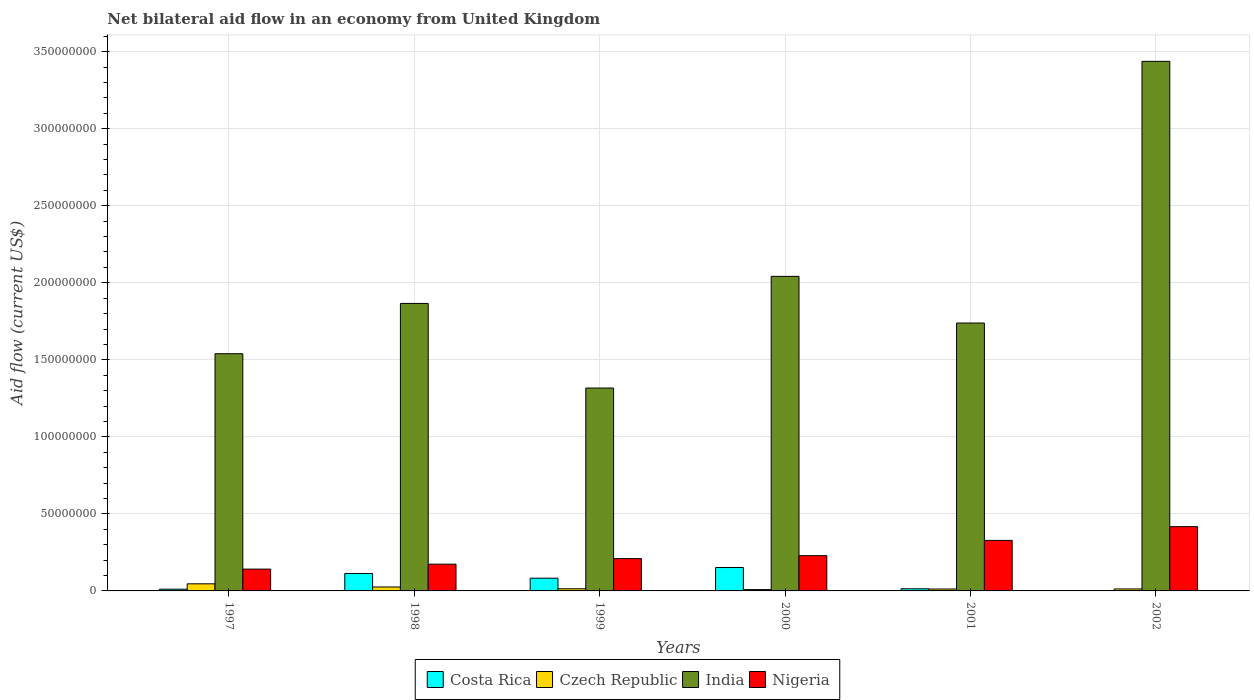How many groups of bars are there?
Provide a short and direct response. 6. Are the number of bars per tick equal to the number of legend labels?
Your answer should be compact. No. Are the number of bars on each tick of the X-axis equal?
Provide a short and direct response. No. How many bars are there on the 4th tick from the right?
Give a very brief answer. 4. What is the label of the 3rd group of bars from the left?
Offer a terse response. 1999. In how many cases, is the number of bars for a given year not equal to the number of legend labels?
Your answer should be compact. 1. What is the net bilateral aid flow in Nigeria in 1999?
Give a very brief answer. 2.10e+07. Across all years, what is the maximum net bilateral aid flow in Nigeria?
Keep it short and to the point. 4.17e+07. Across all years, what is the minimum net bilateral aid flow in Nigeria?
Provide a short and direct response. 1.42e+07. In which year was the net bilateral aid flow in Czech Republic maximum?
Offer a very short reply. 1997. What is the total net bilateral aid flow in India in the graph?
Offer a terse response. 1.19e+09. What is the difference between the net bilateral aid flow in Czech Republic in 1999 and that in 2002?
Provide a succinct answer. 1.10e+05. What is the average net bilateral aid flow in Czech Republic per year?
Provide a short and direct response. 1.99e+06. In the year 1997, what is the difference between the net bilateral aid flow in Costa Rica and net bilateral aid flow in Nigeria?
Offer a very short reply. -1.30e+07. In how many years, is the net bilateral aid flow in Costa Rica greater than 240000000 US$?
Make the answer very short. 0. What is the ratio of the net bilateral aid flow in Nigeria in 1997 to that in 1998?
Your answer should be very brief. 0.82. Is the net bilateral aid flow in Nigeria in 1998 less than that in 1999?
Ensure brevity in your answer.  Yes. What is the difference between the highest and the second highest net bilateral aid flow in Nigeria?
Keep it short and to the point. 8.92e+06. What is the difference between the highest and the lowest net bilateral aid flow in India?
Your response must be concise. 2.12e+08. In how many years, is the net bilateral aid flow in Czech Republic greater than the average net bilateral aid flow in Czech Republic taken over all years?
Offer a very short reply. 2. Is the sum of the net bilateral aid flow in Czech Republic in 1997 and 1998 greater than the maximum net bilateral aid flow in India across all years?
Offer a terse response. No. Is it the case that in every year, the sum of the net bilateral aid flow in India and net bilateral aid flow in Czech Republic is greater than the sum of net bilateral aid flow in Nigeria and net bilateral aid flow in Costa Rica?
Provide a succinct answer. Yes. How many bars are there?
Your response must be concise. 23. How many years are there in the graph?
Provide a succinct answer. 6. What is the difference between two consecutive major ticks on the Y-axis?
Provide a succinct answer. 5.00e+07. Are the values on the major ticks of Y-axis written in scientific E-notation?
Offer a very short reply. No. Does the graph contain any zero values?
Your answer should be very brief. Yes. Where does the legend appear in the graph?
Provide a short and direct response. Bottom center. What is the title of the graph?
Provide a succinct answer. Net bilateral aid flow in an economy from United Kingdom. Does "St. Kitts and Nevis" appear as one of the legend labels in the graph?
Your answer should be very brief. No. What is the Aid flow (current US$) in Costa Rica in 1997?
Provide a succinct answer. 1.12e+06. What is the Aid flow (current US$) in Czech Republic in 1997?
Your answer should be compact. 4.61e+06. What is the Aid flow (current US$) in India in 1997?
Your response must be concise. 1.54e+08. What is the Aid flow (current US$) in Nigeria in 1997?
Your answer should be compact. 1.42e+07. What is the Aid flow (current US$) in Costa Rica in 1998?
Your response must be concise. 1.13e+07. What is the Aid flow (current US$) in Czech Republic in 1998?
Your answer should be very brief. 2.56e+06. What is the Aid flow (current US$) in India in 1998?
Offer a terse response. 1.87e+08. What is the Aid flow (current US$) of Nigeria in 1998?
Your response must be concise. 1.74e+07. What is the Aid flow (current US$) of Costa Rica in 1999?
Make the answer very short. 8.27e+06. What is the Aid flow (current US$) in Czech Republic in 1999?
Keep it short and to the point. 1.39e+06. What is the Aid flow (current US$) in India in 1999?
Your response must be concise. 1.32e+08. What is the Aid flow (current US$) of Nigeria in 1999?
Offer a terse response. 2.10e+07. What is the Aid flow (current US$) in Costa Rica in 2000?
Offer a very short reply. 1.52e+07. What is the Aid flow (current US$) of Czech Republic in 2000?
Offer a very short reply. 8.70e+05. What is the Aid flow (current US$) in India in 2000?
Provide a short and direct response. 2.04e+08. What is the Aid flow (current US$) of Nigeria in 2000?
Keep it short and to the point. 2.29e+07. What is the Aid flow (current US$) in Costa Rica in 2001?
Your response must be concise. 1.39e+06. What is the Aid flow (current US$) in Czech Republic in 2001?
Your answer should be compact. 1.24e+06. What is the Aid flow (current US$) in India in 2001?
Ensure brevity in your answer.  1.74e+08. What is the Aid flow (current US$) in Nigeria in 2001?
Keep it short and to the point. 3.28e+07. What is the Aid flow (current US$) of Costa Rica in 2002?
Your response must be concise. 0. What is the Aid flow (current US$) in Czech Republic in 2002?
Provide a succinct answer. 1.28e+06. What is the Aid flow (current US$) of India in 2002?
Give a very brief answer. 3.44e+08. What is the Aid flow (current US$) in Nigeria in 2002?
Give a very brief answer. 4.17e+07. Across all years, what is the maximum Aid flow (current US$) of Costa Rica?
Offer a very short reply. 1.52e+07. Across all years, what is the maximum Aid flow (current US$) in Czech Republic?
Provide a succinct answer. 4.61e+06. Across all years, what is the maximum Aid flow (current US$) of India?
Keep it short and to the point. 3.44e+08. Across all years, what is the maximum Aid flow (current US$) in Nigeria?
Make the answer very short. 4.17e+07. Across all years, what is the minimum Aid flow (current US$) of Costa Rica?
Offer a terse response. 0. Across all years, what is the minimum Aid flow (current US$) of Czech Republic?
Ensure brevity in your answer.  8.70e+05. Across all years, what is the minimum Aid flow (current US$) of India?
Your response must be concise. 1.32e+08. Across all years, what is the minimum Aid flow (current US$) of Nigeria?
Offer a very short reply. 1.42e+07. What is the total Aid flow (current US$) in Costa Rica in the graph?
Your answer should be very brief. 3.73e+07. What is the total Aid flow (current US$) of Czech Republic in the graph?
Ensure brevity in your answer.  1.20e+07. What is the total Aid flow (current US$) in India in the graph?
Your response must be concise. 1.19e+09. What is the total Aid flow (current US$) in Nigeria in the graph?
Keep it short and to the point. 1.50e+08. What is the difference between the Aid flow (current US$) of Costa Rica in 1997 and that in 1998?
Your answer should be compact. -1.02e+07. What is the difference between the Aid flow (current US$) in Czech Republic in 1997 and that in 1998?
Your answer should be very brief. 2.05e+06. What is the difference between the Aid flow (current US$) in India in 1997 and that in 1998?
Your answer should be compact. -3.26e+07. What is the difference between the Aid flow (current US$) in Nigeria in 1997 and that in 1998?
Your response must be concise. -3.21e+06. What is the difference between the Aid flow (current US$) in Costa Rica in 1997 and that in 1999?
Make the answer very short. -7.15e+06. What is the difference between the Aid flow (current US$) of Czech Republic in 1997 and that in 1999?
Ensure brevity in your answer.  3.22e+06. What is the difference between the Aid flow (current US$) in India in 1997 and that in 1999?
Provide a short and direct response. 2.23e+07. What is the difference between the Aid flow (current US$) in Nigeria in 1997 and that in 1999?
Make the answer very short. -6.83e+06. What is the difference between the Aid flow (current US$) in Costa Rica in 1997 and that in 2000?
Offer a terse response. -1.41e+07. What is the difference between the Aid flow (current US$) in Czech Republic in 1997 and that in 2000?
Provide a succinct answer. 3.74e+06. What is the difference between the Aid flow (current US$) in India in 1997 and that in 2000?
Keep it short and to the point. -5.02e+07. What is the difference between the Aid flow (current US$) in Nigeria in 1997 and that in 2000?
Provide a short and direct response. -8.74e+06. What is the difference between the Aid flow (current US$) of Costa Rica in 1997 and that in 2001?
Ensure brevity in your answer.  -2.70e+05. What is the difference between the Aid flow (current US$) of Czech Republic in 1997 and that in 2001?
Offer a very short reply. 3.37e+06. What is the difference between the Aid flow (current US$) in India in 1997 and that in 2001?
Offer a very short reply. -1.99e+07. What is the difference between the Aid flow (current US$) in Nigeria in 1997 and that in 2001?
Your answer should be compact. -1.86e+07. What is the difference between the Aid flow (current US$) of Czech Republic in 1997 and that in 2002?
Give a very brief answer. 3.33e+06. What is the difference between the Aid flow (current US$) in India in 1997 and that in 2002?
Provide a succinct answer. -1.90e+08. What is the difference between the Aid flow (current US$) of Nigeria in 1997 and that in 2002?
Your response must be concise. -2.76e+07. What is the difference between the Aid flow (current US$) of Costa Rica in 1998 and that in 1999?
Offer a very short reply. 3.06e+06. What is the difference between the Aid flow (current US$) in Czech Republic in 1998 and that in 1999?
Offer a terse response. 1.17e+06. What is the difference between the Aid flow (current US$) in India in 1998 and that in 1999?
Provide a succinct answer. 5.49e+07. What is the difference between the Aid flow (current US$) of Nigeria in 1998 and that in 1999?
Your answer should be very brief. -3.62e+06. What is the difference between the Aid flow (current US$) of Costa Rica in 1998 and that in 2000?
Ensure brevity in your answer.  -3.86e+06. What is the difference between the Aid flow (current US$) of Czech Republic in 1998 and that in 2000?
Your response must be concise. 1.69e+06. What is the difference between the Aid flow (current US$) of India in 1998 and that in 2000?
Offer a very short reply. -1.76e+07. What is the difference between the Aid flow (current US$) in Nigeria in 1998 and that in 2000?
Provide a succinct answer. -5.53e+06. What is the difference between the Aid flow (current US$) in Costa Rica in 1998 and that in 2001?
Ensure brevity in your answer.  9.94e+06. What is the difference between the Aid flow (current US$) of Czech Republic in 1998 and that in 2001?
Provide a short and direct response. 1.32e+06. What is the difference between the Aid flow (current US$) of India in 1998 and that in 2001?
Your response must be concise. 1.27e+07. What is the difference between the Aid flow (current US$) in Nigeria in 1998 and that in 2001?
Make the answer very short. -1.54e+07. What is the difference between the Aid flow (current US$) in Czech Republic in 1998 and that in 2002?
Give a very brief answer. 1.28e+06. What is the difference between the Aid flow (current US$) of India in 1998 and that in 2002?
Give a very brief answer. -1.57e+08. What is the difference between the Aid flow (current US$) in Nigeria in 1998 and that in 2002?
Give a very brief answer. -2.44e+07. What is the difference between the Aid flow (current US$) of Costa Rica in 1999 and that in 2000?
Ensure brevity in your answer.  -6.92e+06. What is the difference between the Aid flow (current US$) in Czech Republic in 1999 and that in 2000?
Offer a terse response. 5.20e+05. What is the difference between the Aid flow (current US$) in India in 1999 and that in 2000?
Provide a succinct answer. -7.25e+07. What is the difference between the Aid flow (current US$) of Nigeria in 1999 and that in 2000?
Your answer should be compact. -1.91e+06. What is the difference between the Aid flow (current US$) in Costa Rica in 1999 and that in 2001?
Provide a short and direct response. 6.88e+06. What is the difference between the Aid flow (current US$) of Czech Republic in 1999 and that in 2001?
Your response must be concise. 1.50e+05. What is the difference between the Aid flow (current US$) in India in 1999 and that in 2001?
Give a very brief answer. -4.22e+07. What is the difference between the Aid flow (current US$) of Nigeria in 1999 and that in 2001?
Ensure brevity in your answer.  -1.18e+07. What is the difference between the Aid flow (current US$) in India in 1999 and that in 2002?
Provide a short and direct response. -2.12e+08. What is the difference between the Aid flow (current US$) in Nigeria in 1999 and that in 2002?
Offer a terse response. -2.07e+07. What is the difference between the Aid flow (current US$) of Costa Rica in 2000 and that in 2001?
Provide a short and direct response. 1.38e+07. What is the difference between the Aid flow (current US$) in Czech Republic in 2000 and that in 2001?
Offer a very short reply. -3.70e+05. What is the difference between the Aid flow (current US$) of India in 2000 and that in 2001?
Your response must be concise. 3.03e+07. What is the difference between the Aid flow (current US$) of Nigeria in 2000 and that in 2001?
Your answer should be very brief. -9.90e+06. What is the difference between the Aid flow (current US$) in Czech Republic in 2000 and that in 2002?
Offer a terse response. -4.10e+05. What is the difference between the Aid flow (current US$) in India in 2000 and that in 2002?
Your response must be concise. -1.40e+08. What is the difference between the Aid flow (current US$) in Nigeria in 2000 and that in 2002?
Give a very brief answer. -1.88e+07. What is the difference between the Aid flow (current US$) in Czech Republic in 2001 and that in 2002?
Give a very brief answer. -4.00e+04. What is the difference between the Aid flow (current US$) in India in 2001 and that in 2002?
Keep it short and to the point. -1.70e+08. What is the difference between the Aid flow (current US$) of Nigeria in 2001 and that in 2002?
Your response must be concise. -8.92e+06. What is the difference between the Aid flow (current US$) of Costa Rica in 1997 and the Aid flow (current US$) of Czech Republic in 1998?
Your answer should be compact. -1.44e+06. What is the difference between the Aid flow (current US$) of Costa Rica in 1997 and the Aid flow (current US$) of India in 1998?
Your answer should be very brief. -1.85e+08. What is the difference between the Aid flow (current US$) in Costa Rica in 1997 and the Aid flow (current US$) in Nigeria in 1998?
Your answer should be compact. -1.62e+07. What is the difference between the Aid flow (current US$) in Czech Republic in 1997 and the Aid flow (current US$) in India in 1998?
Offer a terse response. -1.82e+08. What is the difference between the Aid flow (current US$) of Czech Republic in 1997 and the Aid flow (current US$) of Nigeria in 1998?
Provide a short and direct response. -1.28e+07. What is the difference between the Aid flow (current US$) of India in 1997 and the Aid flow (current US$) of Nigeria in 1998?
Make the answer very short. 1.37e+08. What is the difference between the Aid flow (current US$) of Costa Rica in 1997 and the Aid flow (current US$) of Czech Republic in 1999?
Ensure brevity in your answer.  -2.70e+05. What is the difference between the Aid flow (current US$) of Costa Rica in 1997 and the Aid flow (current US$) of India in 1999?
Give a very brief answer. -1.31e+08. What is the difference between the Aid flow (current US$) of Costa Rica in 1997 and the Aid flow (current US$) of Nigeria in 1999?
Your answer should be very brief. -1.99e+07. What is the difference between the Aid flow (current US$) in Czech Republic in 1997 and the Aid flow (current US$) in India in 1999?
Provide a short and direct response. -1.27e+08. What is the difference between the Aid flow (current US$) in Czech Republic in 1997 and the Aid flow (current US$) in Nigeria in 1999?
Your answer should be very brief. -1.64e+07. What is the difference between the Aid flow (current US$) of India in 1997 and the Aid flow (current US$) of Nigeria in 1999?
Offer a terse response. 1.33e+08. What is the difference between the Aid flow (current US$) in Costa Rica in 1997 and the Aid flow (current US$) in India in 2000?
Make the answer very short. -2.03e+08. What is the difference between the Aid flow (current US$) in Costa Rica in 1997 and the Aid flow (current US$) in Nigeria in 2000?
Your answer should be very brief. -2.18e+07. What is the difference between the Aid flow (current US$) in Czech Republic in 1997 and the Aid flow (current US$) in India in 2000?
Make the answer very short. -2.00e+08. What is the difference between the Aid flow (current US$) of Czech Republic in 1997 and the Aid flow (current US$) of Nigeria in 2000?
Give a very brief answer. -1.83e+07. What is the difference between the Aid flow (current US$) in India in 1997 and the Aid flow (current US$) in Nigeria in 2000?
Provide a short and direct response. 1.31e+08. What is the difference between the Aid flow (current US$) in Costa Rica in 1997 and the Aid flow (current US$) in India in 2001?
Offer a terse response. -1.73e+08. What is the difference between the Aid flow (current US$) in Costa Rica in 1997 and the Aid flow (current US$) in Nigeria in 2001?
Give a very brief answer. -3.17e+07. What is the difference between the Aid flow (current US$) of Czech Republic in 1997 and the Aid flow (current US$) of India in 2001?
Give a very brief answer. -1.69e+08. What is the difference between the Aid flow (current US$) in Czech Republic in 1997 and the Aid flow (current US$) in Nigeria in 2001?
Ensure brevity in your answer.  -2.82e+07. What is the difference between the Aid flow (current US$) in India in 1997 and the Aid flow (current US$) in Nigeria in 2001?
Make the answer very short. 1.21e+08. What is the difference between the Aid flow (current US$) of Costa Rica in 1997 and the Aid flow (current US$) of India in 2002?
Provide a short and direct response. -3.43e+08. What is the difference between the Aid flow (current US$) of Costa Rica in 1997 and the Aid flow (current US$) of Nigeria in 2002?
Make the answer very short. -4.06e+07. What is the difference between the Aid flow (current US$) of Czech Republic in 1997 and the Aid flow (current US$) of India in 2002?
Your response must be concise. -3.39e+08. What is the difference between the Aid flow (current US$) of Czech Republic in 1997 and the Aid flow (current US$) of Nigeria in 2002?
Your answer should be very brief. -3.71e+07. What is the difference between the Aid flow (current US$) of India in 1997 and the Aid flow (current US$) of Nigeria in 2002?
Your response must be concise. 1.12e+08. What is the difference between the Aid flow (current US$) in Costa Rica in 1998 and the Aid flow (current US$) in Czech Republic in 1999?
Provide a succinct answer. 9.94e+06. What is the difference between the Aid flow (current US$) in Costa Rica in 1998 and the Aid flow (current US$) in India in 1999?
Provide a succinct answer. -1.20e+08. What is the difference between the Aid flow (current US$) of Costa Rica in 1998 and the Aid flow (current US$) of Nigeria in 1999?
Make the answer very short. -9.65e+06. What is the difference between the Aid flow (current US$) in Czech Republic in 1998 and the Aid flow (current US$) in India in 1999?
Give a very brief answer. -1.29e+08. What is the difference between the Aid flow (current US$) in Czech Republic in 1998 and the Aid flow (current US$) in Nigeria in 1999?
Your answer should be compact. -1.84e+07. What is the difference between the Aid flow (current US$) in India in 1998 and the Aid flow (current US$) in Nigeria in 1999?
Offer a very short reply. 1.66e+08. What is the difference between the Aid flow (current US$) in Costa Rica in 1998 and the Aid flow (current US$) in Czech Republic in 2000?
Offer a very short reply. 1.05e+07. What is the difference between the Aid flow (current US$) in Costa Rica in 1998 and the Aid flow (current US$) in India in 2000?
Give a very brief answer. -1.93e+08. What is the difference between the Aid flow (current US$) in Costa Rica in 1998 and the Aid flow (current US$) in Nigeria in 2000?
Offer a terse response. -1.16e+07. What is the difference between the Aid flow (current US$) of Czech Republic in 1998 and the Aid flow (current US$) of India in 2000?
Give a very brief answer. -2.02e+08. What is the difference between the Aid flow (current US$) of Czech Republic in 1998 and the Aid flow (current US$) of Nigeria in 2000?
Offer a very short reply. -2.03e+07. What is the difference between the Aid flow (current US$) in India in 1998 and the Aid flow (current US$) in Nigeria in 2000?
Your answer should be compact. 1.64e+08. What is the difference between the Aid flow (current US$) in Costa Rica in 1998 and the Aid flow (current US$) in Czech Republic in 2001?
Provide a succinct answer. 1.01e+07. What is the difference between the Aid flow (current US$) of Costa Rica in 1998 and the Aid flow (current US$) of India in 2001?
Offer a terse response. -1.63e+08. What is the difference between the Aid flow (current US$) in Costa Rica in 1998 and the Aid flow (current US$) in Nigeria in 2001?
Make the answer very short. -2.15e+07. What is the difference between the Aid flow (current US$) of Czech Republic in 1998 and the Aid flow (current US$) of India in 2001?
Your response must be concise. -1.71e+08. What is the difference between the Aid flow (current US$) of Czech Republic in 1998 and the Aid flow (current US$) of Nigeria in 2001?
Offer a very short reply. -3.02e+07. What is the difference between the Aid flow (current US$) in India in 1998 and the Aid flow (current US$) in Nigeria in 2001?
Make the answer very short. 1.54e+08. What is the difference between the Aid flow (current US$) of Costa Rica in 1998 and the Aid flow (current US$) of Czech Republic in 2002?
Provide a short and direct response. 1.00e+07. What is the difference between the Aid flow (current US$) in Costa Rica in 1998 and the Aid flow (current US$) in India in 2002?
Your answer should be very brief. -3.32e+08. What is the difference between the Aid flow (current US$) in Costa Rica in 1998 and the Aid flow (current US$) in Nigeria in 2002?
Your answer should be compact. -3.04e+07. What is the difference between the Aid flow (current US$) of Czech Republic in 1998 and the Aid flow (current US$) of India in 2002?
Offer a terse response. -3.41e+08. What is the difference between the Aid flow (current US$) in Czech Republic in 1998 and the Aid flow (current US$) in Nigeria in 2002?
Your response must be concise. -3.92e+07. What is the difference between the Aid flow (current US$) of India in 1998 and the Aid flow (current US$) of Nigeria in 2002?
Your response must be concise. 1.45e+08. What is the difference between the Aid flow (current US$) of Costa Rica in 1999 and the Aid flow (current US$) of Czech Republic in 2000?
Offer a very short reply. 7.40e+06. What is the difference between the Aid flow (current US$) in Costa Rica in 1999 and the Aid flow (current US$) in India in 2000?
Your response must be concise. -1.96e+08. What is the difference between the Aid flow (current US$) of Costa Rica in 1999 and the Aid flow (current US$) of Nigeria in 2000?
Give a very brief answer. -1.46e+07. What is the difference between the Aid flow (current US$) in Czech Republic in 1999 and the Aid flow (current US$) in India in 2000?
Offer a terse response. -2.03e+08. What is the difference between the Aid flow (current US$) of Czech Republic in 1999 and the Aid flow (current US$) of Nigeria in 2000?
Make the answer very short. -2.15e+07. What is the difference between the Aid flow (current US$) in India in 1999 and the Aid flow (current US$) in Nigeria in 2000?
Offer a terse response. 1.09e+08. What is the difference between the Aid flow (current US$) in Costa Rica in 1999 and the Aid flow (current US$) in Czech Republic in 2001?
Provide a succinct answer. 7.03e+06. What is the difference between the Aid flow (current US$) in Costa Rica in 1999 and the Aid flow (current US$) in India in 2001?
Give a very brief answer. -1.66e+08. What is the difference between the Aid flow (current US$) of Costa Rica in 1999 and the Aid flow (current US$) of Nigeria in 2001?
Provide a short and direct response. -2.45e+07. What is the difference between the Aid flow (current US$) of Czech Republic in 1999 and the Aid flow (current US$) of India in 2001?
Give a very brief answer. -1.72e+08. What is the difference between the Aid flow (current US$) of Czech Republic in 1999 and the Aid flow (current US$) of Nigeria in 2001?
Offer a terse response. -3.14e+07. What is the difference between the Aid flow (current US$) of India in 1999 and the Aid flow (current US$) of Nigeria in 2001?
Your answer should be compact. 9.89e+07. What is the difference between the Aid flow (current US$) of Costa Rica in 1999 and the Aid flow (current US$) of Czech Republic in 2002?
Provide a succinct answer. 6.99e+06. What is the difference between the Aid flow (current US$) of Costa Rica in 1999 and the Aid flow (current US$) of India in 2002?
Your response must be concise. -3.35e+08. What is the difference between the Aid flow (current US$) in Costa Rica in 1999 and the Aid flow (current US$) in Nigeria in 2002?
Ensure brevity in your answer.  -3.34e+07. What is the difference between the Aid flow (current US$) of Czech Republic in 1999 and the Aid flow (current US$) of India in 2002?
Your response must be concise. -3.42e+08. What is the difference between the Aid flow (current US$) in Czech Republic in 1999 and the Aid flow (current US$) in Nigeria in 2002?
Ensure brevity in your answer.  -4.03e+07. What is the difference between the Aid flow (current US$) of India in 1999 and the Aid flow (current US$) of Nigeria in 2002?
Provide a succinct answer. 9.00e+07. What is the difference between the Aid flow (current US$) of Costa Rica in 2000 and the Aid flow (current US$) of Czech Republic in 2001?
Give a very brief answer. 1.40e+07. What is the difference between the Aid flow (current US$) of Costa Rica in 2000 and the Aid flow (current US$) of India in 2001?
Offer a terse response. -1.59e+08. What is the difference between the Aid flow (current US$) in Costa Rica in 2000 and the Aid flow (current US$) in Nigeria in 2001?
Make the answer very short. -1.76e+07. What is the difference between the Aid flow (current US$) of Czech Republic in 2000 and the Aid flow (current US$) of India in 2001?
Provide a short and direct response. -1.73e+08. What is the difference between the Aid flow (current US$) in Czech Republic in 2000 and the Aid flow (current US$) in Nigeria in 2001?
Your answer should be very brief. -3.19e+07. What is the difference between the Aid flow (current US$) of India in 2000 and the Aid flow (current US$) of Nigeria in 2001?
Give a very brief answer. 1.71e+08. What is the difference between the Aid flow (current US$) of Costa Rica in 2000 and the Aid flow (current US$) of Czech Republic in 2002?
Ensure brevity in your answer.  1.39e+07. What is the difference between the Aid flow (current US$) in Costa Rica in 2000 and the Aid flow (current US$) in India in 2002?
Provide a succinct answer. -3.29e+08. What is the difference between the Aid flow (current US$) in Costa Rica in 2000 and the Aid flow (current US$) in Nigeria in 2002?
Provide a short and direct response. -2.65e+07. What is the difference between the Aid flow (current US$) in Czech Republic in 2000 and the Aid flow (current US$) in India in 2002?
Provide a short and direct response. -3.43e+08. What is the difference between the Aid flow (current US$) in Czech Republic in 2000 and the Aid flow (current US$) in Nigeria in 2002?
Your answer should be compact. -4.08e+07. What is the difference between the Aid flow (current US$) in India in 2000 and the Aid flow (current US$) in Nigeria in 2002?
Ensure brevity in your answer.  1.62e+08. What is the difference between the Aid flow (current US$) of Costa Rica in 2001 and the Aid flow (current US$) of India in 2002?
Your answer should be very brief. -3.42e+08. What is the difference between the Aid flow (current US$) of Costa Rica in 2001 and the Aid flow (current US$) of Nigeria in 2002?
Keep it short and to the point. -4.03e+07. What is the difference between the Aid flow (current US$) in Czech Republic in 2001 and the Aid flow (current US$) in India in 2002?
Offer a terse response. -3.42e+08. What is the difference between the Aid flow (current US$) of Czech Republic in 2001 and the Aid flow (current US$) of Nigeria in 2002?
Ensure brevity in your answer.  -4.05e+07. What is the difference between the Aid flow (current US$) in India in 2001 and the Aid flow (current US$) in Nigeria in 2002?
Offer a terse response. 1.32e+08. What is the average Aid flow (current US$) of Costa Rica per year?
Provide a short and direct response. 6.22e+06. What is the average Aid flow (current US$) of Czech Republic per year?
Give a very brief answer. 1.99e+06. What is the average Aid flow (current US$) in India per year?
Provide a short and direct response. 1.99e+08. What is the average Aid flow (current US$) of Nigeria per year?
Make the answer very short. 2.50e+07. In the year 1997, what is the difference between the Aid flow (current US$) of Costa Rica and Aid flow (current US$) of Czech Republic?
Provide a short and direct response. -3.49e+06. In the year 1997, what is the difference between the Aid flow (current US$) of Costa Rica and Aid flow (current US$) of India?
Your response must be concise. -1.53e+08. In the year 1997, what is the difference between the Aid flow (current US$) of Costa Rica and Aid flow (current US$) of Nigeria?
Provide a short and direct response. -1.30e+07. In the year 1997, what is the difference between the Aid flow (current US$) of Czech Republic and Aid flow (current US$) of India?
Provide a short and direct response. -1.49e+08. In the year 1997, what is the difference between the Aid flow (current US$) in Czech Republic and Aid flow (current US$) in Nigeria?
Offer a very short reply. -9.54e+06. In the year 1997, what is the difference between the Aid flow (current US$) of India and Aid flow (current US$) of Nigeria?
Give a very brief answer. 1.40e+08. In the year 1998, what is the difference between the Aid flow (current US$) in Costa Rica and Aid flow (current US$) in Czech Republic?
Make the answer very short. 8.77e+06. In the year 1998, what is the difference between the Aid flow (current US$) in Costa Rica and Aid flow (current US$) in India?
Offer a terse response. -1.75e+08. In the year 1998, what is the difference between the Aid flow (current US$) of Costa Rica and Aid flow (current US$) of Nigeria?
Keep it short and to the point. -6.03e+06. In the year 1998, what is the difference between the Aid flow (current US$) of Czech Republic and Aid flow (current US$) of India?
Ensure brevity in your answer.  -1.84e+08. In the year 1998, what is the difference between the Aid flow (current US$) in Czech Republic and Aid flow (current US$) in Nigeria?
Provide a short and direct response. -1.48e+07. In the year 1998, what is the difference between the Aid flow (current US$) in India and Aid flow (current US$) in Nigeria?
Give a very brief answer. 1.69e+08. In the year 1999, what is the difference between the Aid flow (current US$) of Costa Rica and Aid flow (current US$) of Czech Republic?
Keep it short and to the point. 6.88e+06. In the year 1999, what is the difference between the Aid flow (current US$) in Costa Rica and Aid flow (current US$) in India?
Your response must be concise. -1.23e+08. In the year 1999, what is the difference between the Aid flow (current US$) in Costa Rica and Aid flow (current US$) in Nigeria?
Give a very brief answer. -1.27e+07. In the year 1999, what is the difference between the Aid flow (current US$) in Czech Republic and Aid flow (current US$) in India?
Give a very brief answer. -1.30e+08. In the year 1999, what is the difference between the Aid flow (current US$) of Czech Republic and Aid flow (current US$) of Nigeria?
Offer a terse response. -1.96e+07. In the year 1999, what is the difference between the Aid flow (current US$) in India and Aid flow (current US$) in Nigeria?
Make the answer very short. 1.11e+08. In the year 2000, what is the difference between the Aid flow (current US$) in Costa Rica and Aid flow (current US$) in Czech Republic?
Your response must be concise. 1.43e+07. In the year 2000, what is the difference between the Aid flow (current US$) in Costa Rica and Aid flow (current US$) in India?
Provide a short and direct response. -1.89e+08. In the year 2000, what is the difference between the Aid flow (current US$) of Costa Rica and Aid flow (current US$) of Nigeria?
Make the answer very short. -7.70e+06. In the year 2000, what is the difference between the Aid flow (current US$) in Czech Republic and Aid flow (current US$) in India?
Provide a succinct answer. -2.03e+08. In the year 2000, what is the difference between the Aid flow (current US$) of Czech Republic and Aid flow (current US$) of Nigeria?
Provide a short and direct response. -2.20e+07. In the year 2000, what is the difference between the Aid flow (current US$) in India and Aid flow (current US$) in Nigeria?
Your response must be concise. 1.81e+08. In the year 2001, what is the difference between the Aid flow (current US$) in Costa Rica and Aid flow (current US$) in Czech Republic?
Your answer should be very brief. 1.50e+05. In the year 2001, what is the difference between the Aid flow (current US$) in Costa Rica and Aid flow (current US$) in India?
Give a very brief answer. -1.72e+08. In the year 2001, what is the difference between the Aid flow (current US$) in Costa Rica and Aid flow (current US$) in Nigeria?
Provide a succinct answer. -3.14e+07. In the year 2001, what is the difference between the Aid flow (current US$) in Czech Republic and Aid flow (current US$) in India?
Make the answer very short. -1.73e+08. In the year 2001, what is the difference between the Aid flow (current US$) in Czech Republic and Aid flow (current US$) in Nigeria?
Your answer should be very brief. -3.16e+07. In the year 2001, what is the difference between the Aid flow (current US$) of India and Aid flow (current US$) of Nigeria?
Your answer should be compact. 1.41e+08. In the year 2002, what is the difference between the Aid flow (current US$) in Czech Republic and Aid flow (current US$) in India?
Make the answer very short. -3.42e+08. In the year 2002, what is the difference between the Aid flow (current US$) in Czech Republic and Aid flow (current US$) in Nigeria?
Make the answer very short. -4.04e+07. In the year 2002, what is the difference between the Aid flow (current US$) in India and Aid flow (current US$) in Nigeria?
Provide a short and direct response. 3.02e+08. What is the ratio of the Aid flow (current US$) in Costa Rica in 1997 to that in 1998?
Provide a succinct answer. 0.1. What is the ratio of the Aid flow (current US$) in Czech Republic in 1997 to that in 1998?
Your answer should be compact. 1.8. What is the ratio of the Aid flow (current US$) of India in 1997 to that in 1998?
Keep it short and to the point. 0.83. What is the ratio of the Aid flow (current US$) in Nigeria in 1997 to that in 1998?
Provide a short and direct response. 0.82. What is the ratio of the Aid flow (current US$) in Costa Rica in 1997 to that in 1999?
Offer a terse response. 0.14. What is the ratio of the Aid flow (current US$) of Czech Republic in 1997 to that in 1999?
Give a very brief answer. 3.32. What is the ratio of the Aid flow (current US$) of India in 1997 to that in 1999?
Offer a very short reply. 1.17. What is the ratio of the Aid flow (current US$) of Nigeria in 1997 to that in 1999?
Offer a very short reply. 0.67. What is the ratio of the Aid flow (current US$) in Costa Rica in 1997 to that in 2000?
Provide a succinct answer. 0.07. What is the ratio of the Aid flow (current US$) of Czech Republic in 1997 to that in 2000?
Give a very brief answer. 5.3. What is the ratio of the Aid flow (current US$) of India in 1997 to that in 2000?
Make the answer very short. 0.75. What is the ratio of the Aid flow (current US$) in Nigeria in 1997 to that in 2000?
Your answer should be compact. 0.62. What is the ratio of the Aid flow (current US$) in Costa Rica in 1997 to that in 2001?
Provide a short and direct response. 0.81. What is the ratio of the Aid flow (current US$) of Czech Republic in 1997 to that in 2001?
Offer a very short reply. 3.72. What is the ratio of the Aid flow (current US$) of India in 1997 to that in 2001?
Your response must be concise. 0.89. What is the ratio of the Aid flow (current US$) in Nigeria in 1997 to that in 2001?
Give a very brief answer. 0.43. What is the ratio of the Aid flow (current US$) in Czech Republic in 1997 to that in 2002?
Ensure brevity in your answer.  3.6. What is the ratio of the Aid flow (current US$) of India in 1997 to that in 2002?
Offer a very short reply. 0.45. What is the ratio of the Aid flow (current US$) in Nigeria in 1997 to that in 2002?
Your answer should be very brief. 0.34. What is the ratio of the Aid flow (current US$) of Costa Rica in 1998 to that in 1999?
Provide a short and direct response. 1.37. What is the ratio of the Aid flow (current US$) of Czech Republic in 1998 to that in 1999?
Ensure brevity in your answer.  1.84. What is the ratio of the Aid flow (current US$) of India in 1998 to that in 1999?
Offer a very short reply. 1.42. What is the ratio of the Aid flow (current US$) of Nigeria in 1998 to that in 1999?
Provide a succinct answer. 0.83. What is the ratio of the Aid flow (current US$) in Costa Rica in 1998 to that in 2000?
Keep it short and to the point. 0.75. What is the ratio of the Aid flow (current US$) in Czech Republic in 1998 to that in 2000?
Offer a very short reply. 2.94. What is the ratio of the Aid flow (current US$) of India in 1998 to that in 2000?
Make the answer very short. 0.91. What is the ratio of the Aid flow (current US$) in Nigeria in 1998 to that in 2000?
Offer a terse response. 0.76. What is the ratio of the Aid flow (current US$) in Costa Rica in 1998 to that in 2001?
Offer a terse response. 8.15. What is the ratio of the Aid flow (current US$) of Czech Republic in 1998 to that in 2001?
Provide a succinct answer. 2.06. What is the ratio of the Aid flow (current US$) in India in 1998 to that in 2001?
Keep it short and to the point. 1.07. What is the ratio of the Aid flow (current US$) in Nigeria in 1998 to that in 2001?
Your answer should be very brief. 0.53. What is the ratio of the Aid flow (current US$) of India in 1998 to that in 2002?
Your response must be concise. 0.54. What is the ratio of the Aid flow (current US$) of Nigeria in 1998 to that in 2002?
Provide a succinct answer. 0.42. What is the ratio of the Aid flow (current US$) of Costa Rica in 1999 to that in 2000?
Your answer should be compact. 0.54. What is the ratio of the Aid flow (current US$) in Czech Republic in 1999 to that in 2000?
Offer a terse response. 1.6. What is the ratio of the Aid flow (current US$) in India in 1999 to that in 2000?
Your answer should be compact. 0.65. What is the ratio of the Aid flow (current US$) of Nigeria in 1999 to that in 2000?
Offer a terse response. 0.92. What is the ratio of the Aid flow (current US$) in Costa Rica in 1999 to that in 2001?
Make the answer very short. 5.95. What is the ratio of the Aid flow (current US$) of Czech Republic in 1999 to that in 2001?
Provide a short and direct response. 1.12. What is the ratio of the Aid flow (current US$) in India in 1999 to that in 2001?
Provide a succinct answer. 0.76. What is the ratio of the Aid flow (current US$) in Nigeria in 1999 to that in 2001?
Offer a terse response. 0.64. What is the ratio of the Aid flow (current US$) in Czech Republic in 1999 to that in 2002?
Your answer should be compact. 1.09. What is the ratio of the Aid flow (current US$) in India in 1999 to that in 2002?
Offer a very short reply. 0.38. What is the ratio of the Aid flow (current US$) of Nigeria in 1999 to that in 2002?
Offer a very short reply. 0.5. What is the ratio of the Aid flow (current US$) in Costa Rica in 2000 to that in 2001?
Offer a very short reply. 10.93. What is the ratio of the Aid flow (current US$) of Czech Republic in 2000 to that in 2001?
Offer a very short reply. 0.7. What is the ratio of the Aid flow (current US$) of India in 2000 to that in 2001?
Offer a terse response. 1.17. What is the ratio of the Aid flow (current US$) in Nigeria in 2000 to that in 2001?
Make the answer very short. 0.7. What is the ratio of the Aid flow (current US$) of Czech Republic in 2000 to that in 2002?
Offer a very short reply. 0.68. What is the ratio of the Aid flow (current US$) of India in 2000 to that in 2002?
Ensure brevity in your answer.  0.59. What is the ratio of the Aid flow (current US$) of Nigeria in 2000 to that in 2002?
Keep it short and to the point. 0.55. What is the ratio of the Aid flow (current US$) in Czech Republic in 2001 to that in 2002?
Your answer should be compact. 0.97. What is the ratio of the Aid flow (current US$) of India in 2001 to that in 2002?
Keep it short and to the point. 0.51. What is the ratio of the Aid flow (current US$) of Nigeria in 2001 to that in 2002?
Provide a succinct answer. 0.79. What is the difference between the highest and the second highest Aid flow (current US$) in Costa Rica?
Your answer should be very brief. 3.86e+06. What is the difference between the highest and the second highest Aid flow (current US$) in Czech Republic?
Provide a succinct answer. 2.05e+06. What is the difference between the highest and the second highest Aid flow (current US$) of India?
Keep it short and to the point. 1.40e+08. What is the difference between the highest and the second highest Aid flow (current US$) in Nigeria?
Give a very brief answer. 8.92e+06. What is the difference between the highest and the lowest Aid flow (current US$) in Costa Rica?
Make the answer very short. 1.52e+07. What is the difference between the highest and the lowest Aid flow (current US$) of Czech Republic?
Ensure brevity in your answer.  3.74e+06. What is the difference between the highest and the lowest Aid flow (current US$) in India?
Provide a succinct answer. 2.12e+08. What is the difference between the highest and the lowest Aid flow (current US$) in Nigeria?
Provide a short and direct response. 2.76e+07. 